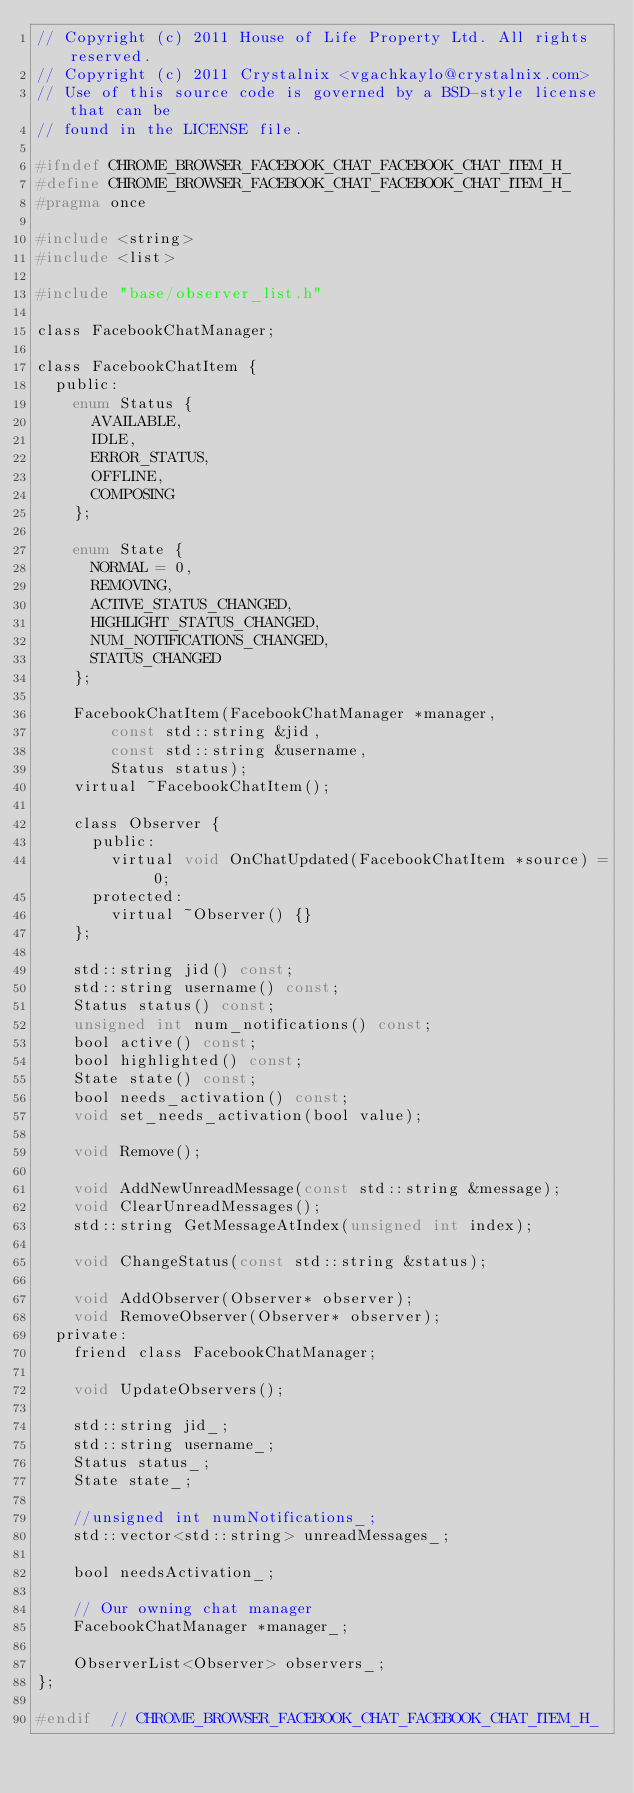<code> <loc_0><loc_0><loc_500><loc_500><_C_>// Copyright (c) 2011 House of Life Property Ltd. All rights reserved.
// Copyright (c) 2011 Crystalnix <vgachkaylo@crystalnix.com>
// Use of this source code is governed by a BSD-style license that can be
// found in the LICENSE file.

#ifndef CHROME_BROWSER_FACEBOOK_CHAT_FACEBOOK_CHAT_ITEM_H_
#define CHROME_BROWSER_FACEBOOK_CHAT_FACEBOOK_CHAT_ITEM_H_
#pragma once

#include <string>
#include <list>

#include "base/observer_list.h"

class FacebookChatManager;

class FacebookChatItem {
  public:
    enum Status {
      AVAILABLE,
      IDLE,
      ERROR_STATUS,
      OFFLINE,
      COMPOSING
    };

    enum State {
      NORMAL = 0,
      REMOVING,
      ACTIVE_STATUS_CHANGED,
      HIGHLIGHT_STATUS_CHANGED,
      NUM_NOTIFICATIONS_CHANGED,
      STATUS_CHANGED
    };

    FacebookChatItem(FacebookChatManager *manager,
        const std::string &jid,
        const std::string &username,
        Status status);
    virtual ~FacebookChatItem();

    class Observer {
      public:
        virtual void OnChatUpdated(FacebookChatItem *source) = 0;
      protected:
        virtual ~Observer() {}
    };

    std::string jid() const;
    std::string username() const;
    Status status() const;
    unsigned int num_notifications() const;
    bool active() const;
    bool highlighted() const;
    State state() const;
    bool needs_activation() const;
    void set_needs_activation(bool value);

    void Remove();

    void AddNewUnreadMessage(const std::string &message);
    void ClearUnreadMessages();
    std::string GetMessageAtIndex(unsigned int index);

    void ChangeStatus(const std::string &status);

    void AddObserver(Observer* observer);
    void RemoveObserver(Observer* observer);
  private:
    friend class FacebookChatManager;

    void UpdateObservers();

    std::string jid_;
    std::string username_;
    Status status_;
    State state_;

    //unsigned int numNotifications_;
    std::vector<std::string> unreadMessages_;

    bool needsActivation_;

    // Our owning chat manager
    FacebookChatManager *manager_;

    ObserverList<Observer> observers_;
};

#endif  // CHROME_BROWSER_FACEBOOK_CHAT_FACEBOOK_CHAT_ITEM_H_

</code> 